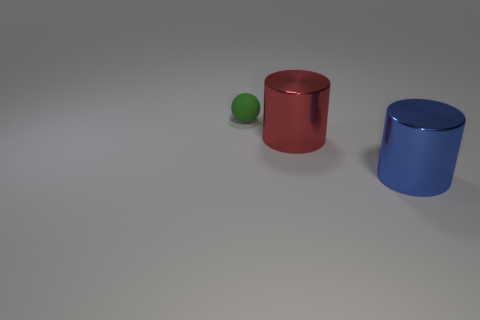Add 2 tiny blue shiny spheres. How many objects exist? 5 Subtract all spheres. How many objects are left? 2 Add 2 large red objects. How many large red objects are left? 3 Add 1 blue things. How many blue things exist? 2 Subtract 0 brown cubes. How many objects are left? 3 Subtract all big metal cylinders. Subtract all green things. How many objects are left? 0 